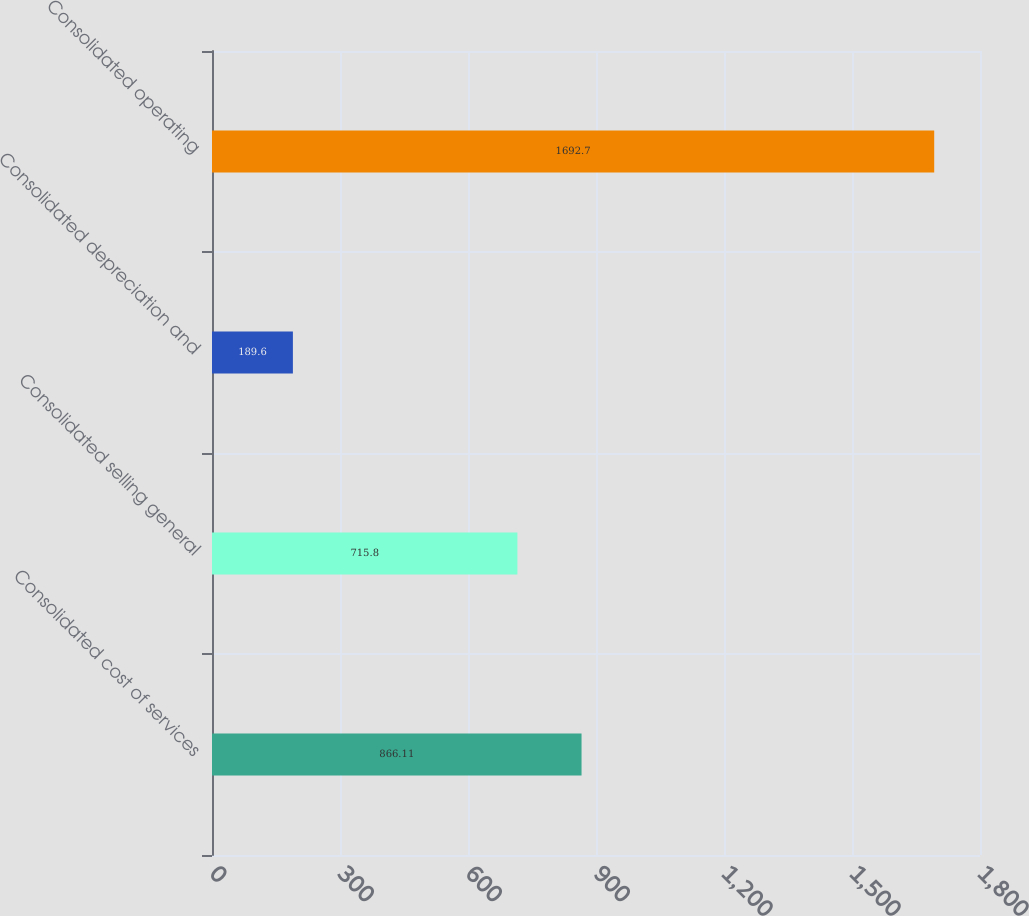Convert chart. <chart><loc_0><loc_0><loc_500><loc_500><bar_chart><fcel>Consolidated cost of services<fcel>Consolidated selling general<fcel>Consolidated depreciation and<fcel>Consolidated operating<nl><fcel>866.11<fcel>715.8<fcel>189.6<fcel>1692.7<nl></chart> 